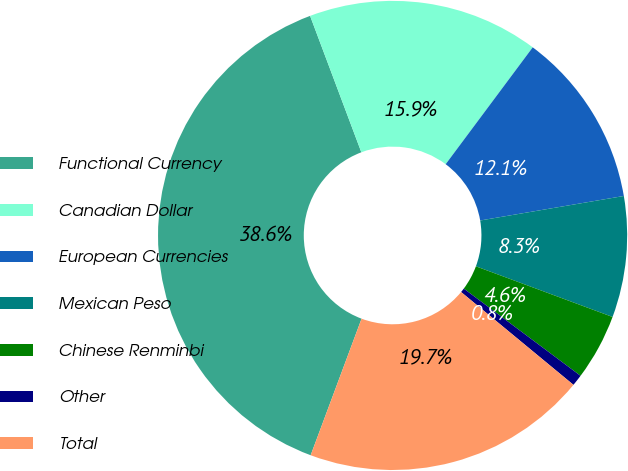Convert chart to OTSL. <chart><loc_0><loc_0><loc_500><loc_500><pie_chart><fcel>Functional Currency<fcel>Canadian Dollar<fcel>European Currencies<fcel>Mexican Peso<fcel>Chinese Renminbi<fcel>Other<fcel>Total<nl><fcel>38.6%<fcel>15.91%<fcel>12.12%<fcel>8.34%<fcel>4.56%<fcel>0.78%<fcel>19.69%<nl></chart> 